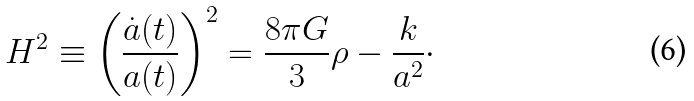<formula> <loc_0><loc_0><loc_500><loc_500>H ^ { 2 } \equiv \left ( \frac { \dot { a } ( t ) } { a ( t ) } \right ) ^ { 2 } = \frac { 8 \pi G } { 3 } \rho - \frac { k } { a ^ { 2 } } \cdot</formula> 